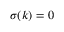<formula> <loc_0><loc_0><loc_500><loc_500>\sigma ( k ) = 0</formula> 